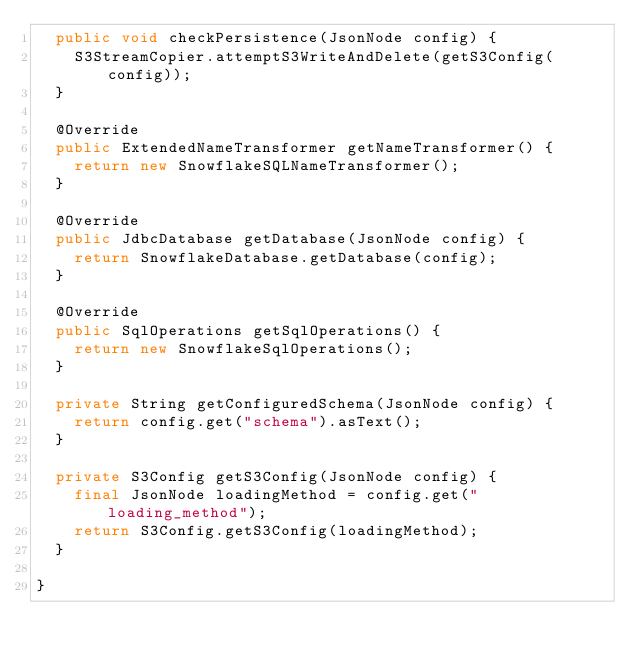<code> <loc_0><loc_0><loc_500><loc_500><_Java_>  public void checkPersistence(JsonNode config) {
    S3StreamCopier.attemptS3WriteAndDelete(getS3Config(config));
  }

  @Override
  public ExtendedNameTransformer getNameTransformer() {
    return new SnowflakeSQLNameTransformer();
  }

  @Override
  public JdbcDatabase getDatabase(JsonNode config) {
    return SnowflakeDatabase.getDatabase(config);
  }

  @Override
  public SqlOperations getSqlOperations() {
    return new SnowflakeSqlOperations();
  }

  private String getConfiguredSchema(JsonNode config) {
    return config.get("schema").asText();
  }

  private S3Config getS3Config(JsonNode config) {
    final JsonNode loadingMethod = config.get("loading_method");
    return S3Config.getS3Config(loadingMethod);
  }

}
</code> 